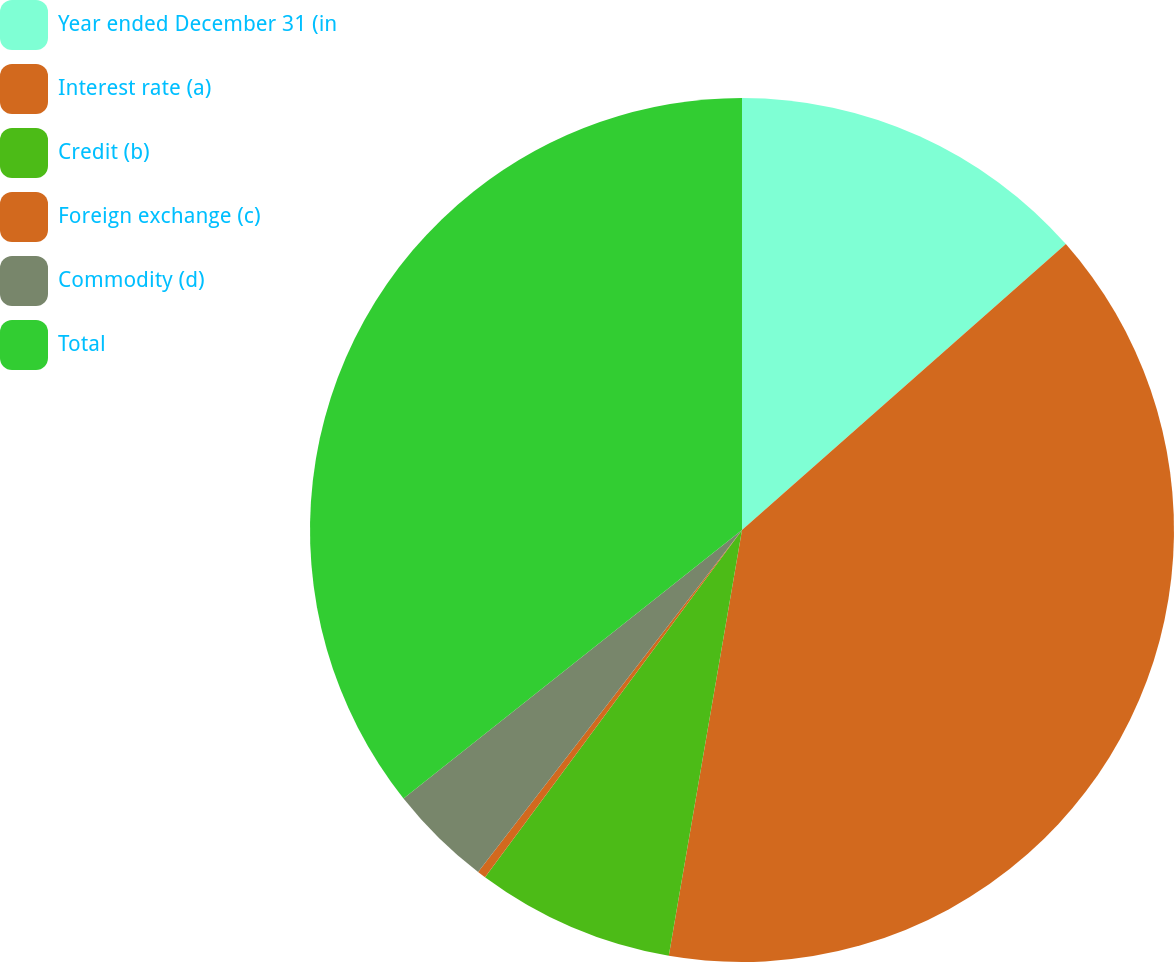Convert chart to OTSL. <chart><loc_0><loc_0><loc_500><loc_500><pie_chart><fcel>Year ended December 31 (in<fcel>Interest rate (a)<fcel>Credit (b)<fcel>Foreign exchange (c)<fcel>Commodity (d)<fcel>Total<nl><fcel>13.49%<fcel>39.22%<fcel>7.43%<fcel>0.32%<fcel>3.87%<fcel>35.67%<nl></chart> 